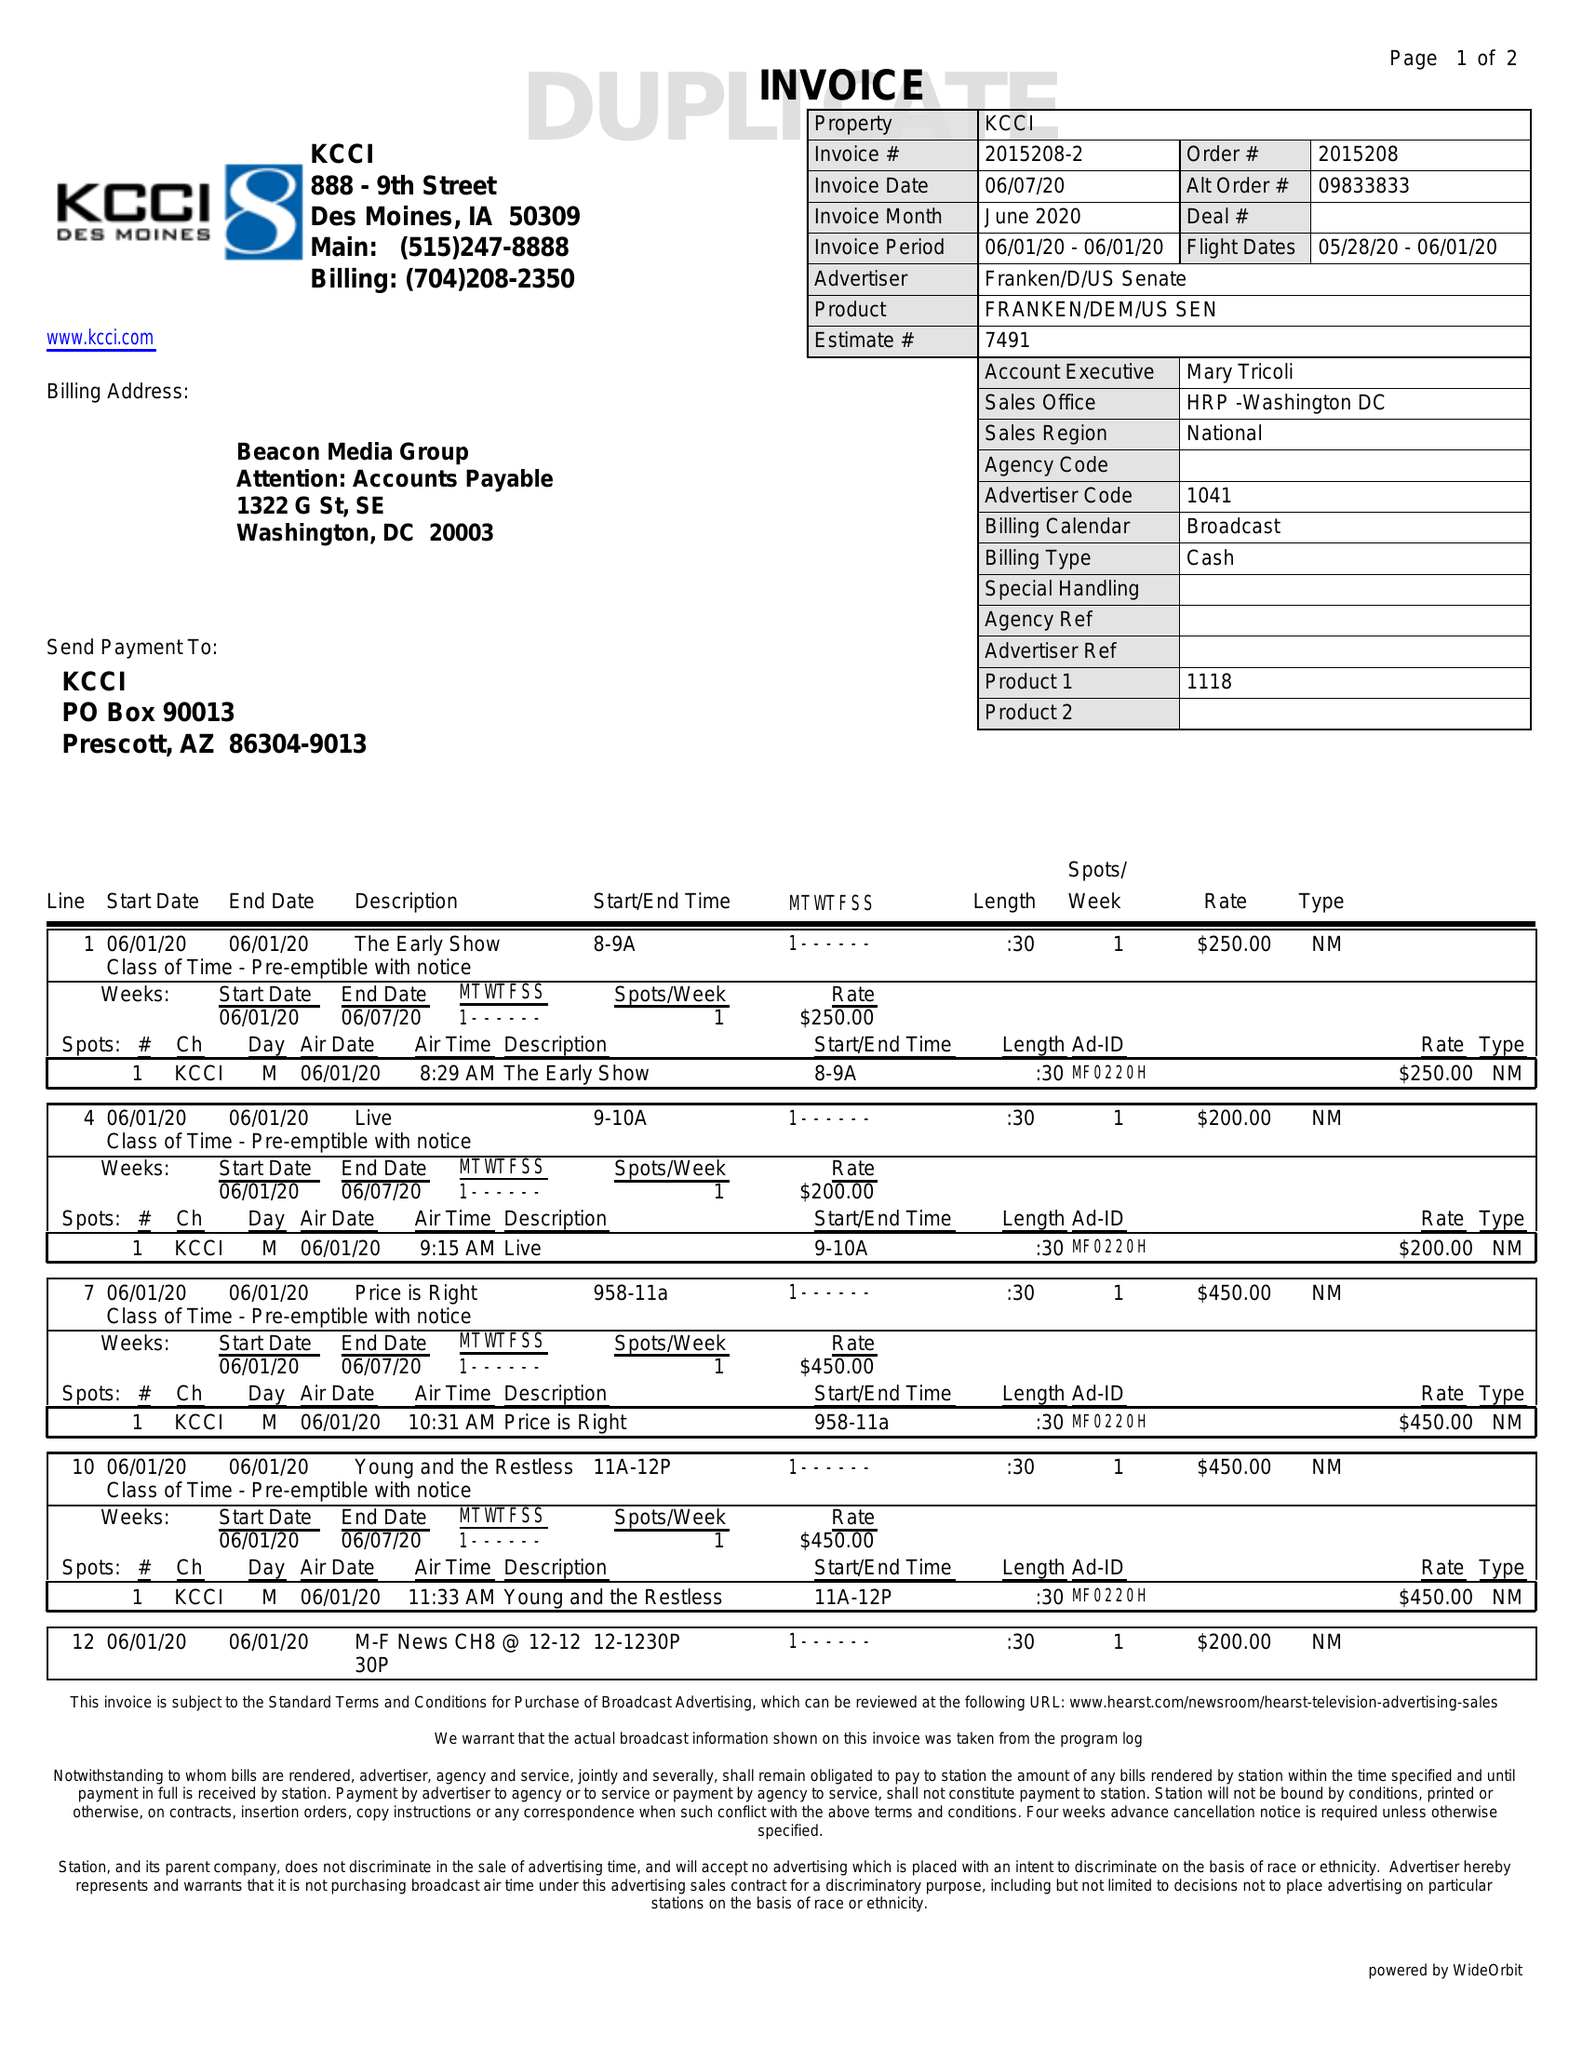What is the value for the gross_amount?
Answer the question using a single word or phrase. 2150.00 